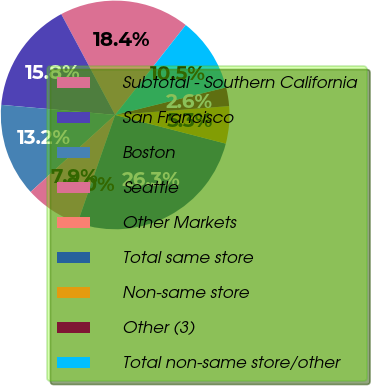Convert chart. <chart><loc_0><loc_0><loc_500><loc_500><pie_chart><fcel>Subtotal - Southern California<fcel>San Francisco<fcel>Boston<fcel>Seattle<fcel>Other Markets<fcel>Total same store<fcel>Non-same store<fcel>Other (3)<fcel>Total non-same store/other<nl><fcel>18.41%<fcel>15.78%<fcel>13.16%<fcel>7.9%<fcel>0.01%<fcel>26.3%<fcel>5.27%<fcel>2.64%<fcel>10.53%<nl></chart> 